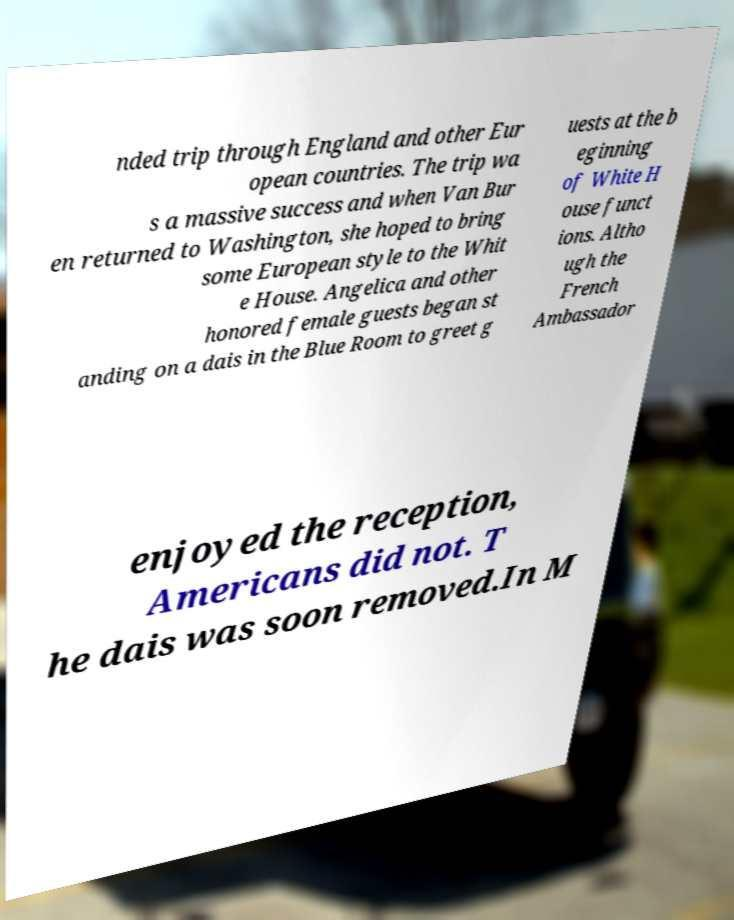Please read and relay the text visible in this image. What does it say? nded trip through England and other Eur opean countries. The trip wa s a massive success and when Van Bur en returned to Washington, she hoped to bring some European style to the Whit e House. Angelica and other honored female guests began st anding on a dais in the Blue Room to greet g uests at the b eginning of White H ouse funct ions. Altho ugh the French Ambassador enjoyed the reception, Americans did not. T he dais was soon removed.In M 